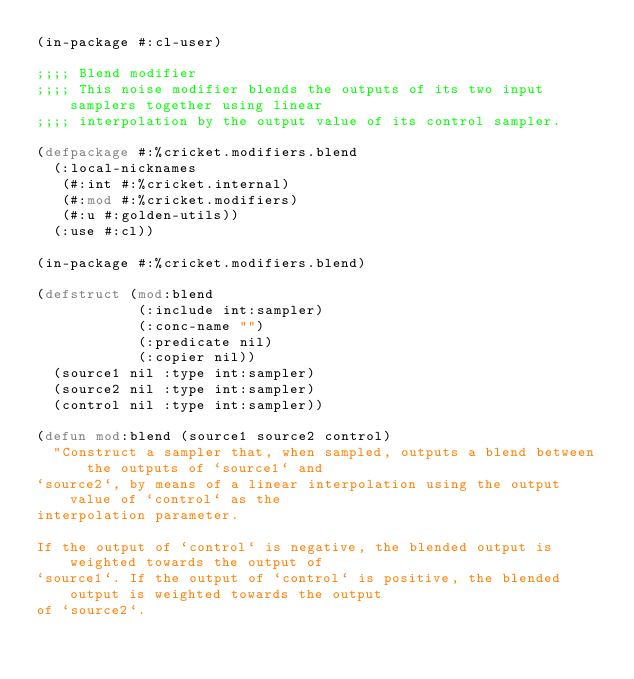Convert code to text. <code><loc_0><loc_0><loc_500><loc_500><_Lisp_>(in-package #:cl-user)

;;;; Blend modifier
;;;; This noise modifier blends the outputs of its two input samplers together using linear
;;;; interpolation by the output value of its control sampler.

(defpackage #:%cricket.modifiers.blend
  (:local-nicknames
   (#:int #:%cricket.internal)
   (#:mod #:%cricket.modifiers)
   (#:u #:golden-utils))
  (:use #:cl))

(in-package #:%cricket.modifiers.blend)

(defstruct (mod:blend
            (:include int:sampler)
            (:conc-name "")
            (:predicate nil)
            (:copier nil))
  (source1 nil :type int:sampler)
  (source2 nil :type int:sampler)
  (control nil :type int:sampler))

(defun mod:blend (source1 source2 control)
  "Construct a sampler that, when sampled, outputs a blend between the outputs of `source1` and
`source2`, by means of a linear interpolation using the output value of `control` as the
interpolation parameter.

If the output of `control` is negative, the blended output is weighted towards the output of
`source1`. If the output of `control` is positive, the blended output is weighted towards the output
of `source2`.
</code> 